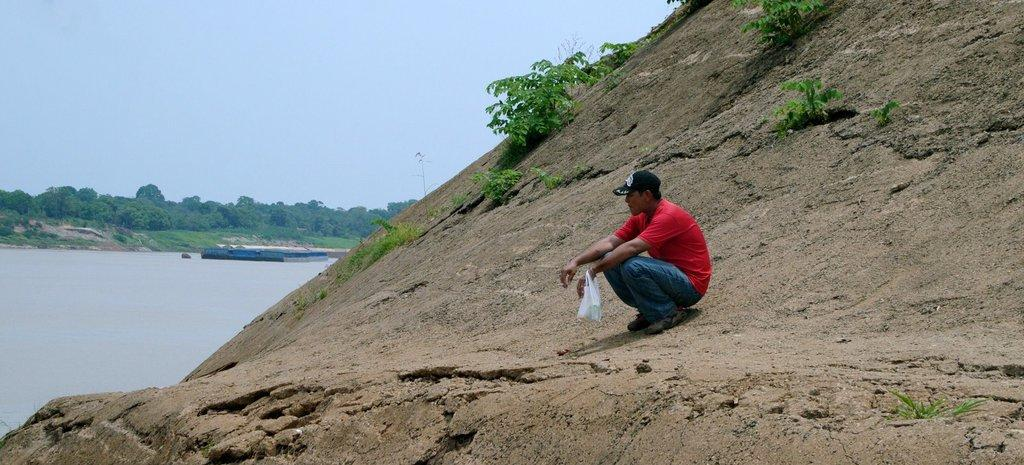Who or what is in the front of the image? There is a person in the front of the image. What is on the rock surface in the image? There are plants on a rock surface. What can be seen on the left side of the image? There are trees and the sky visible on the left side of the image. What else is visible on the left side of the image? There is water visible on the left side of the image. What type of error can be seen in the image? There is no error present in the image. How many planes are visible in the image? There are no planes visible in the image. 